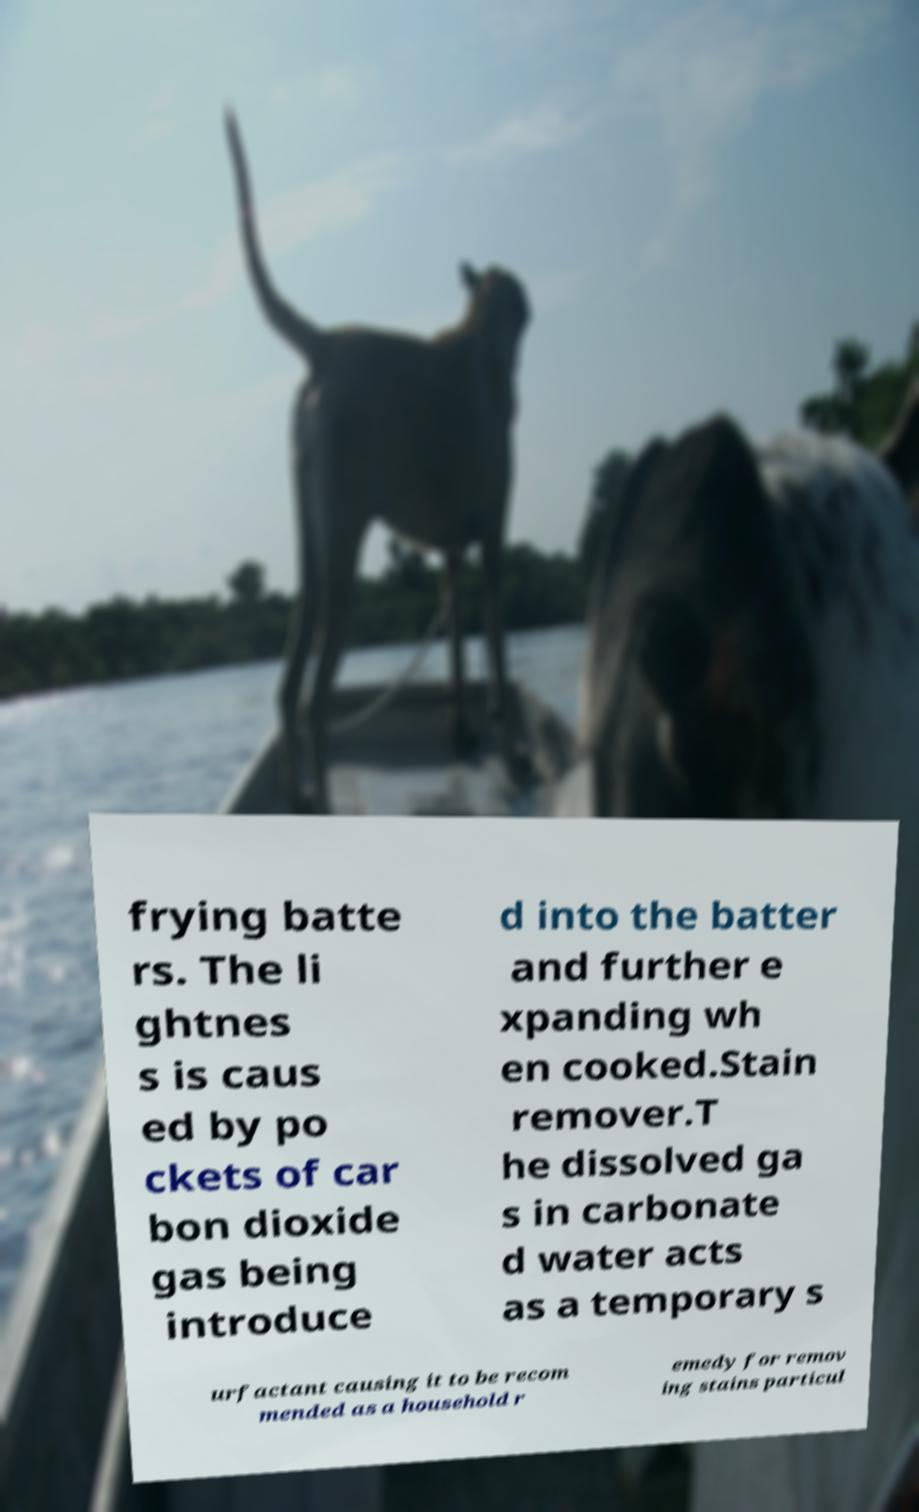Could you assist in decoding the text presented in this image and type it out clearly? frying batte rs. The li ghtnes s is caus ed by po ckets of car bon dioxide gas being introduce d into the batter and further e xpanding wh en cooked.Stain remover.T he dissolved ga s in carbonate d water acts as a temporary s urfactant causing it to be recom mended as a household r emedy for remov ing stains particul 